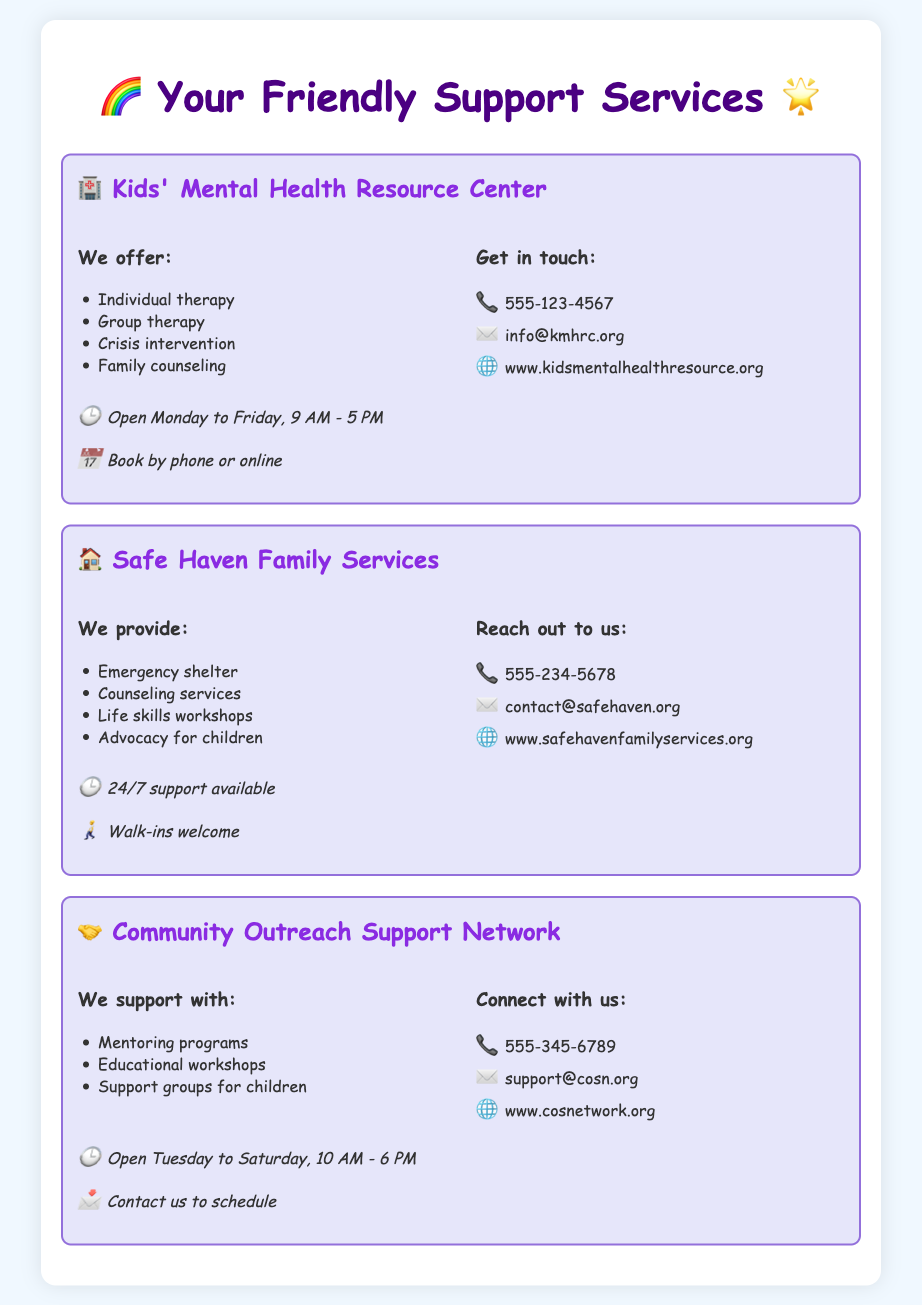What services does the Kids' Mental Health Resource Center offer? The document lists individual therapy, group therapy, crisis intervention, and family counseling as services offered at the Kids' Mental Health Resource Center.
Answer: Individual therapy, group therapy, crisis intervention, family counseling What is the contact number for Safe Haven Family Services? The document states that Safe Haven Family Services can be reached at the contact number 555-234-5678.
Answer: 555-234-5678 When is the Community Outreach Support Network open? The document specifies that the Community Outreach Support Network is open Tuesday to Saturday, 10 AM - 6 PM.
Answer: Tuesday to Saturday, 10 AM - 6 PM What types of workshops does Safe Haven Family Services provide? The document mentions that Safe Haven Family Services offers life skills workshops as part of their services.
Answer: Life skills workshops What is the email address for the Kids' Mental Health Resource Center? The document provides the email address info@kmhrc.org for contacting the Kids' Mental Health Resource Center.
Answer: info@kmhrc.org How can you schedule an appointment with the Community Outreach Support Network? The document indicates that you need to contact them to schedule an appointment.
Answer: Contact us to schedule What support is available from Safe Haven Family Services? The document notes that Safe Haven Family Services provides counseling services and emergency shelter, among other supports.
Answer: Emergency shelter, counseling services How can you book an appointment with the Kids' Mental Health Resource Center? The document explains that appointments can be booked by phone or online.
Answer: Book by phone or online 